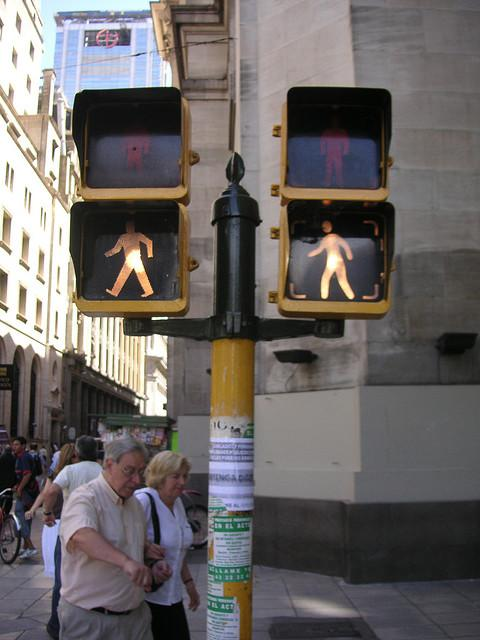What is the traffic light permitting? Please explain your reasoning. crossing. There is a white icon of a person walking in the traffic light. 